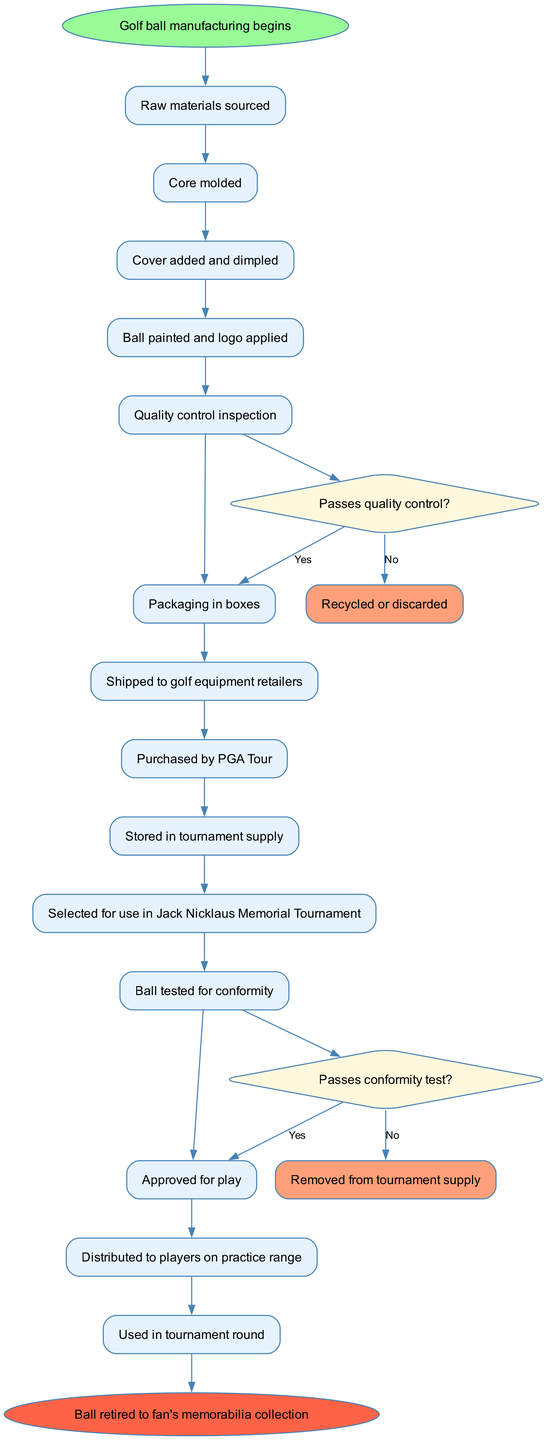What is the starting point of the journey in this diagram? The diagram begins with the node labeled "Golf ball manufacturing begins," which signifies the starting point of the entire process.
Answer: Golf ball manufacturing begins How many activities are listed in the diagram? There are 13 activities listed in the activities section of the diagram, each representing a specific step in the journey of the golf ball.
Answer: 13 What happens if the ball fails the quality control inspection? If the ball fails the quality control inspection, the flow indicates it will be "Recycled or discarded," which is displayed on the alternate pathway connected to the decision node regarding quality control.
Answer: Recycled or discarded What is the final node in the diagram? The final node in the flow of the diagram is labeled "Ball retired to fan's memorabilia collection," which marks the end of the golf ball's journey.
Answer: Ball retired to fan's memorabilia collection How does a golf ball get selected for use in the Jack Nicklaus Memorial Tournament? The flow indicates that after "Stored in tournament supply," the ball is then "Selected for use in Jack Nicklaus Memorial Tournament," demonstrating the sequence in which selection occurs.
Answer: Selected for use in Jack Nicklaus Memorial Tournament What condition must be met for the ball to be approved for play? The ball must "Passes conformity test?" as indicated in the decision node, which determines whether it can proceed to the step of being approved for play.
Answer: Passes conformity test How many decisions are made during the golf ball's journey? There are 2 decision points identified in the diagram, which are about passing quality control and passing the conformity test, indicating critical points of evaluation in the process.
Answer: 2 What is the path taken if the ball passes quality control? If the ball passes quality control, the path leads to "Packaging in boxes," indicating the next step the ball undergoes in its journey.
Answer: Packaging in boxes What is the outcome if the ball is selected and then fails the conformity test? If the ball is selected and then fails the conformity test, it will be "Removed from tournament supply," thus indicating a critical evaluation point after selection.
Answer: Removed from tournament supply 